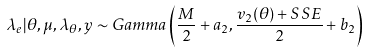<formula> <loc_0><loc_0><loc_500><loc_500>\lambda _ { e } | \theta , \mu , \lambda _ { \theta } , y \sim G a m m a \left ( \frac { M } { 2 } + a _ { 2 } , \frac { v _ { 2 } ( \theta ) + S S E } { 2 } + b _ { 2 } \right )</formula> 